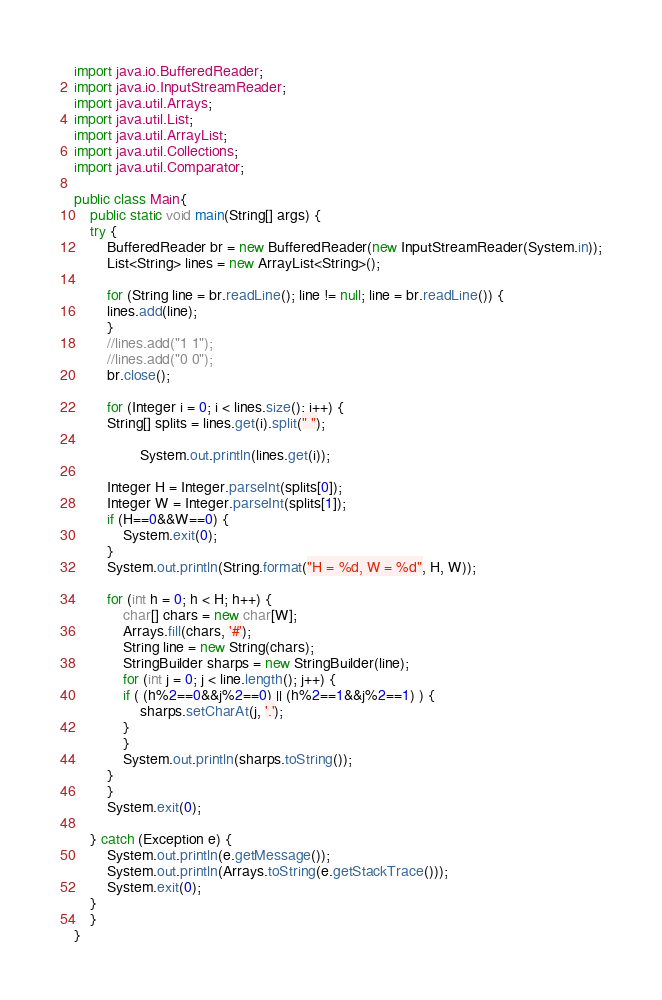Convert code to text. <code><loc_0><loc_0><loc_500><loc_500><_Java_>import java.io.BufferedReader;
import java.io.InputStreamReader;
import java.util.Arrays;
import java.util.List;
import java.util.ArrayList;
import java.util.Collections;
import java.util.Comparator;

public class Main{
    public static void main(String[] args) {
	try {
	    BufferedReader br = new BufferedReader(new InputStreamReader(System.in));
	    List<String> lines = new ArrayList<String>();

	    for (String line = br.readLine(); line != null; line = br.readLine()) {
		lines.add(line);
	    }
	    //lines.add("1 1");
	    //lines.add("0 0");
	    br.close();

	    for (Integer i = 0; i < lines.size(); i++) {
		String[] splits = lines.get(i).split(" ");

                System.out.println(lines.get(i));

		Integer H = Integer.parseInt(splits[0]);
		Integer W = Integer.parseInt(splits[1]);
		if (H==0&&W==0) {
		    System.exit(0);
		}
		System.out.println(String.format("H = %d, W = %d", H, W));

		for (int h = 0; h < H; h++) {
		    char[] chars = new char[W];
		    Arrays.fill(chars, '#');
		    String line = new String(chars);
		    StringBuilder sharps = new StringBuilder(line);
		    for (int j = 0; j < line.length(); j++) {
			if ( (h%2==0&&j%2==0) || (h%2==1&&j%2==1) ) {
			    sharps.setCharAt(j, '.');
			}
		    }
		    System.out.println(sharps.toString());
		}
	    }
	    System.exit(0);

	} catch (Exception e) {
	    System.out.println(e.getMessage());
	    System.out.println(Arrays.toString(e.getStackTrace()));
	    System.exit(0);
	}
    }
}</code> 